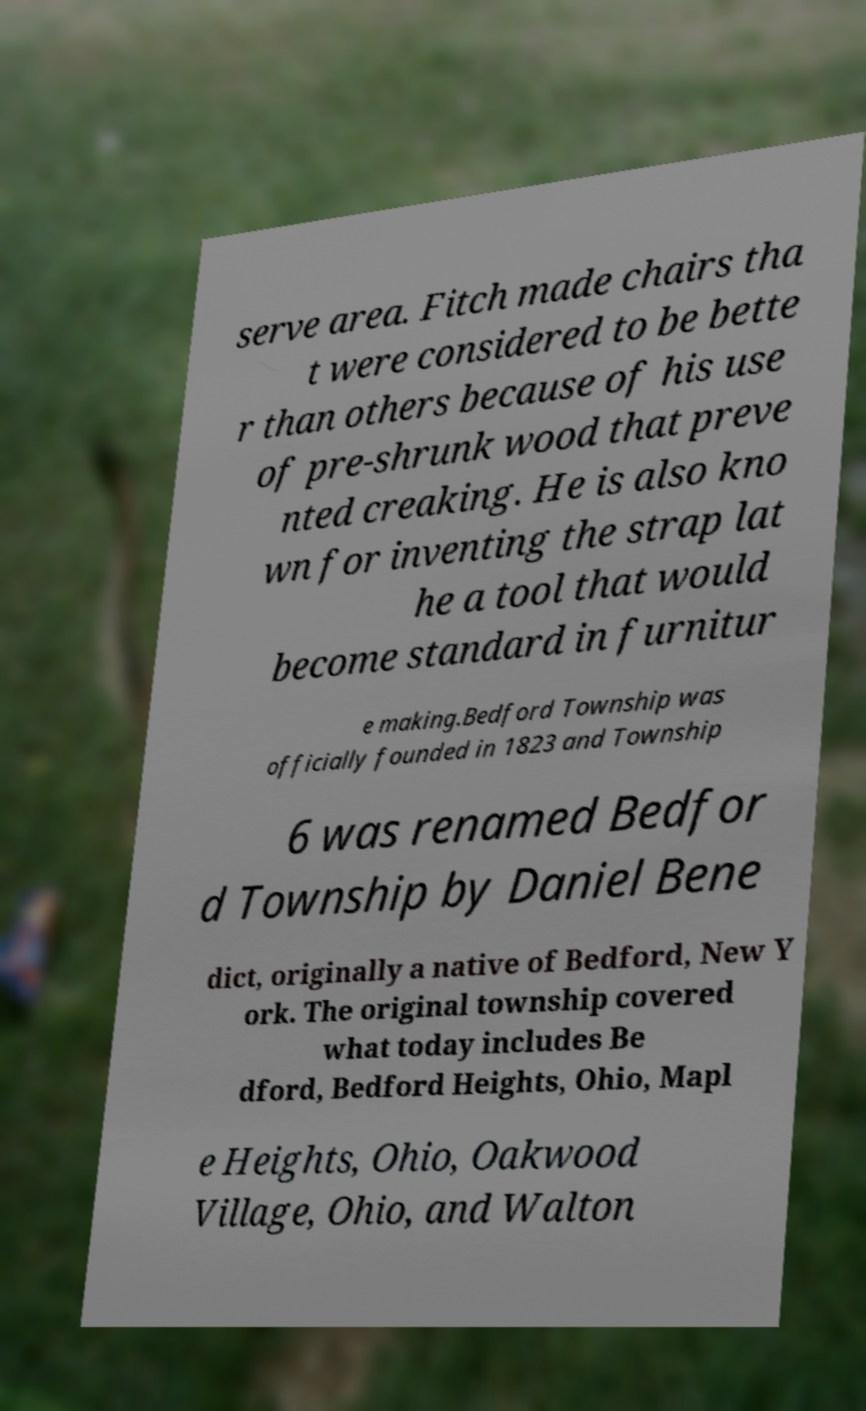Could you extract and type out the text from this image? serve area. Fitch made chairs tha t were considered to be bette r than others because of his use of pre-shrunk wood that preve nted creaking. He is also kno wn for inventing the strap lat he a tool that would become standard in furnitur e making.Bedford Township was officially founded in 1823 and Township 6 was renamed Bedfor d Township by Daniel Bene dict, originally a native of Bedford, New Y ork. The original township covered what today includes Be dford, Bedford Heights, Ohio, Mapl e Heights, Ohio, Oakwood Village, Ohio, and Walton 